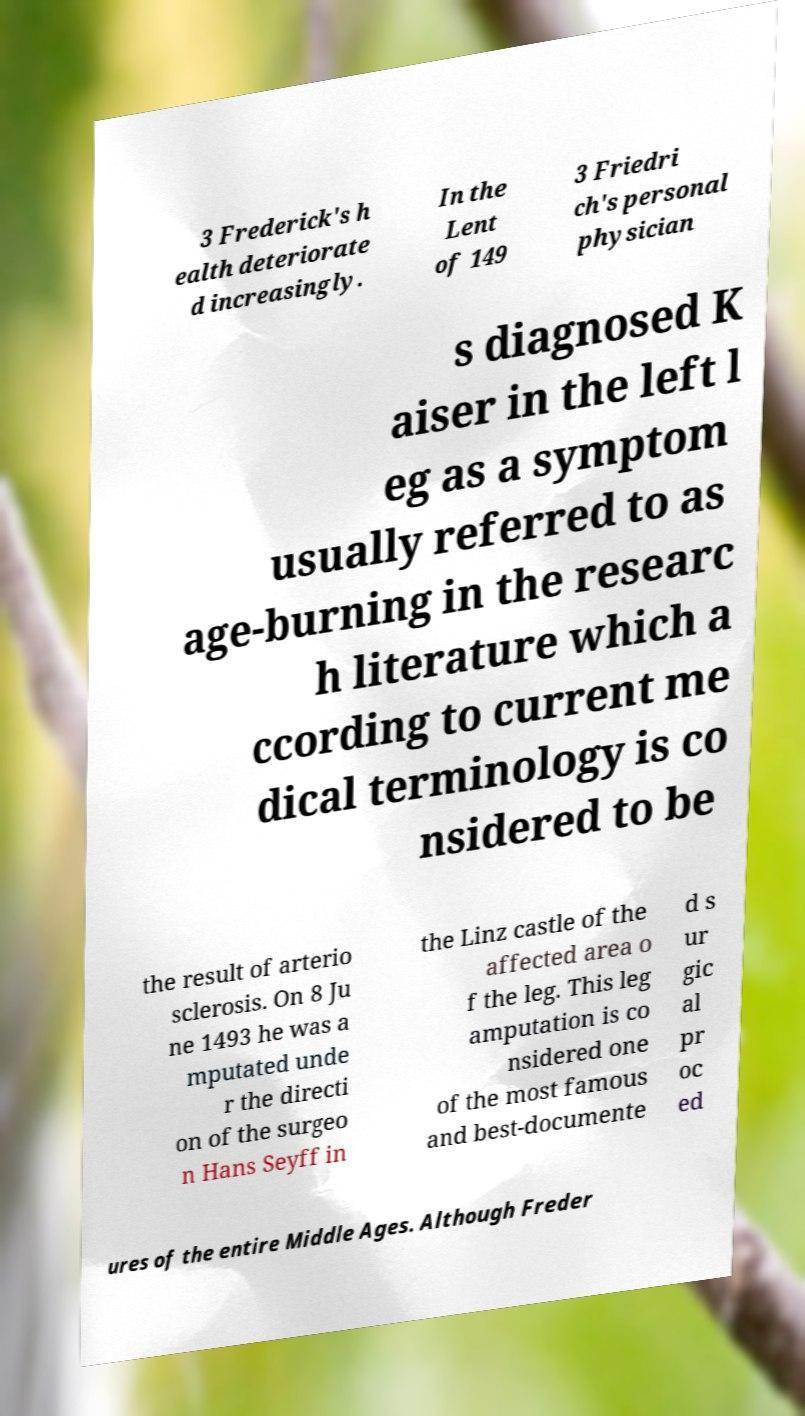Can you read and provide the text displayed in the image?This photo seems to have some interesting text. Can you extract and type it out for me? 3 Frederick's h ealth deteriorate d increasingly. In the Lent of 149 3 Friedri ch's personal physician s diagnosed K aiser in the left l eg as a symptom usually referred to as age-burning in the researc h literature which a ccording to current me dical terminology is co nsidered to be the result of arterio sclerosis. On 8 Ju ne 1493 he was a mputated unde r the directi on of the surgeo n Hans Seyff in the Linz castle of the affected area o f the leg. This leg amputation is co nsidered one of the most famous and best-documente d s ur gic al pr oc ed ures of the entire Middle Ages. Although Freder 